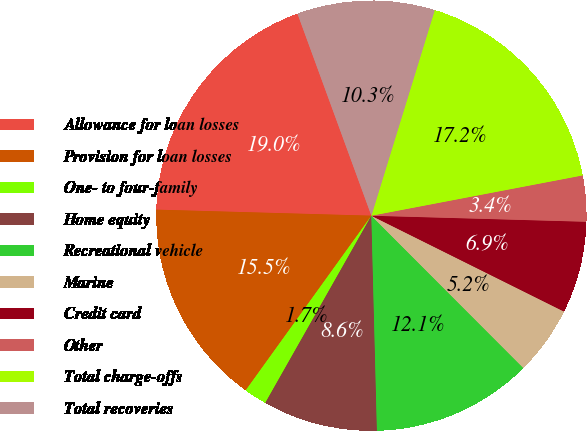Convert chart to OTSL. <chart><loc_0><loc_0><loc_500><loc_500><pie_chart><fcel>Allowance for loan losses<fcel>Provision for loan losses<fcel>One- to four-family<fcel>Home equity<fcel>Recreational vehicle<fcel>Marine<fcel>Credit card<fcel>Other<fcel>Total charge-offs<fcel>Total recoveries<nl><fcel>18.97%<fcel>15.52%<fcel>1.72%<fcel>8.62%<fcel>12.07%<fcel>5.17%<fcel>6.9%<fcel>3.45%<fcel>17.24%<fcel>10.34%<nl></chart> 